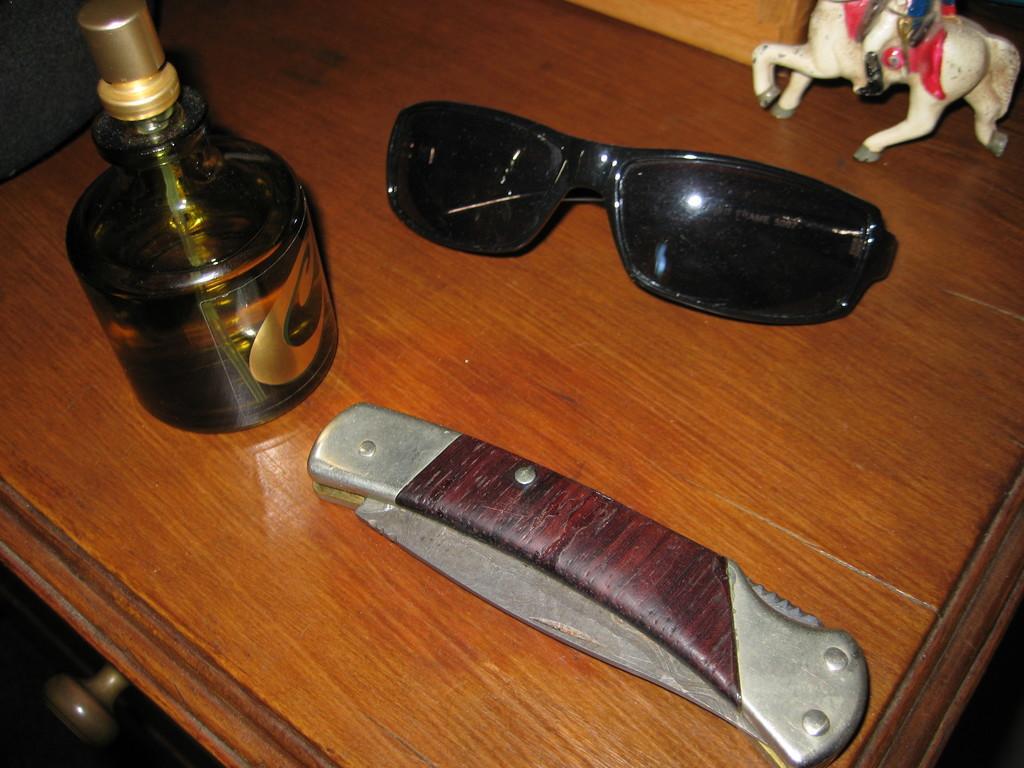In one or two sentences, can you explain what this image depicts? In this image there is a table and we can see glasses, knife, perfume and a figurine placed on the table. 